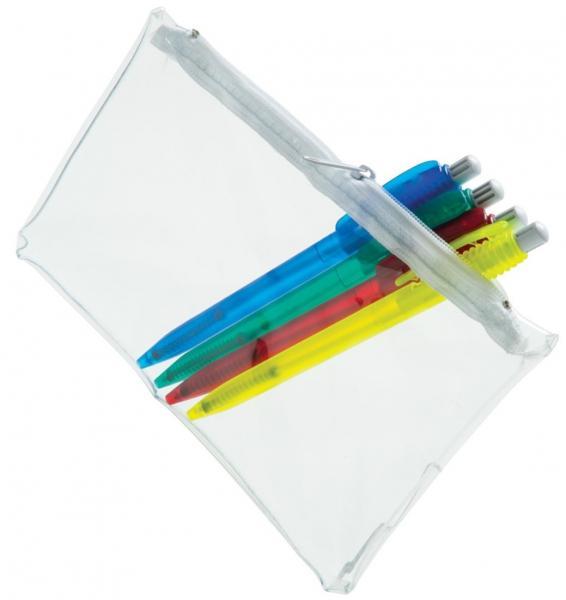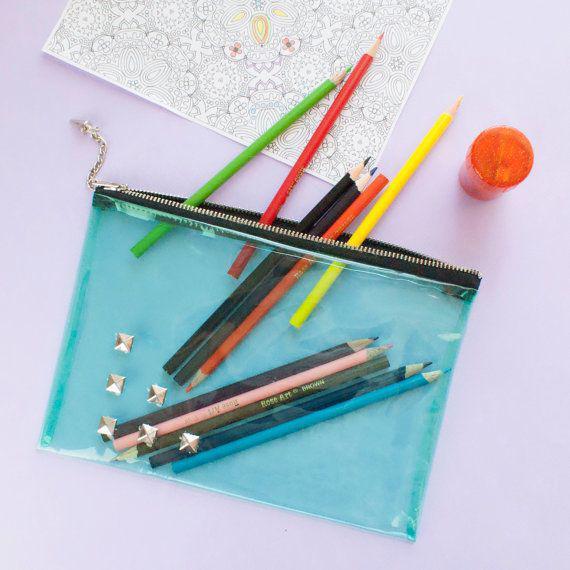The first image is the image on the left, the second image is the image on the right. For the images shown, is this caption "There are exactly two translucent pencil pouches." true? Answer yes or no. Yes. The first image is the image on the left, the second image is the image on the right. Analyze the images presented: Is the assertion "There are exactly two pouches in total." valid? Answer yes or no. Yes. 